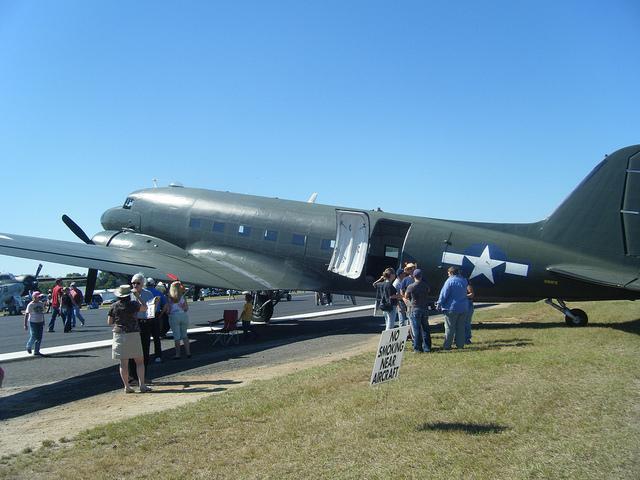How many airplanes are there?
Give a very brief answer. 1. How many people can you see?
Give a very brief answer. 2. 